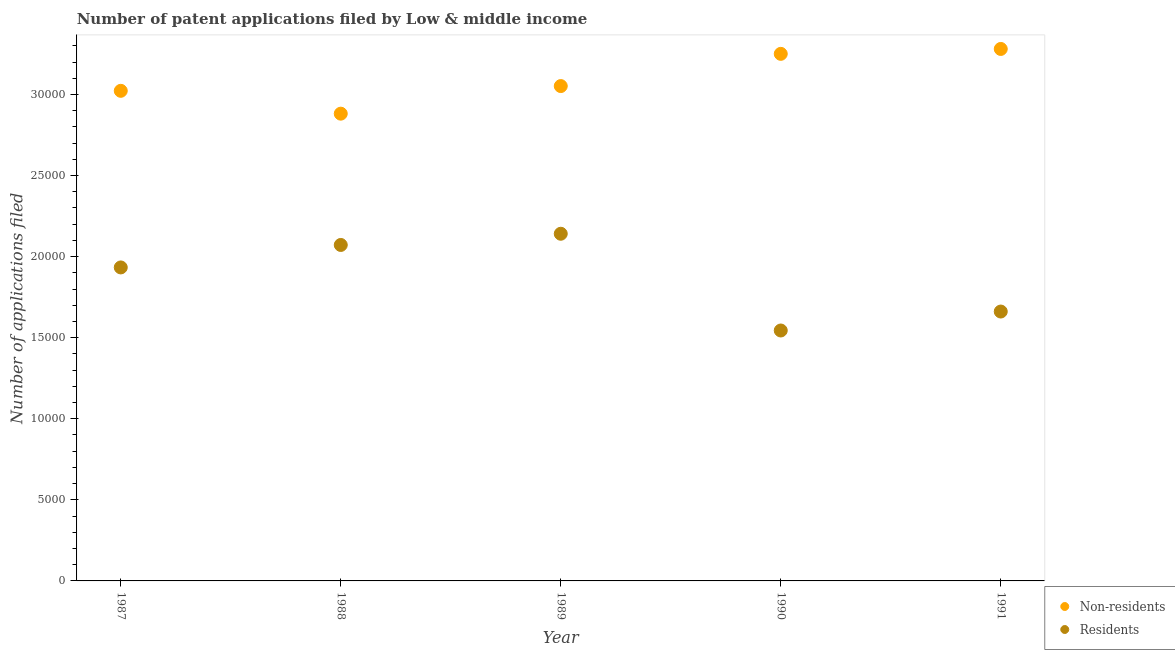How many different coloured dotlines are there?
Make the answer very short. 2. What is the number of patent applications by non residents in 1990?
Offer a terse response. 3.25e+04. Across all years, what is the maximum number of patent applications by non residents?
Ensure brevity in your answer.  3.28e+04. Across all years, what is the minimum number of patent applications by residents?
Keep it short and to the point. 1.54e+04. In which year was the number of patent applications by non residents minimum?
Ensure brevity in your answer.  1988. What is the total number of patent applications by non residents in the graph?
Provide a succinct answer. 1.55e+05. What is the difference between the number of patent applications by residents in 1987 and that in 1991?
Make the answer very short. 2720. What is the difference between the number of patent applications by non residents in 1987 and the number of patent applications by residents in 1988?
Provide a short and direct response. 9505. What is the average number of patent applications by non residents per year?
Ensure brevity in your answer.  3.10e+04. In the year 1987, what is the difference between the number of patent applications by non residents and number of patent applications by residents?
Keep it short and to the point. 1.09e+04. What is the ratio of the number of patent applications by residents in 1987 to that in 1989?
Make the answer very short. 0.9. What is the difference between the highest and the second highest number of patent applications by non residents?
Keep it short and to the point. 302. What is the difference between the highest and the lowest number of patent applications by non residents?
Offer a very short reply. 3991. How many years are there in the graph?
Provide a short and direct response. 5. What is the difference between two consecutive major ticks on the Y-axis?
Provide a succinct answer. 5000. Where does the legend appear in the graph?
Your response must be concise. Bottom right. What is the title of the graph?
Offer a terse response. Number of patent applications filed by Low & middle income. Does "Under-5(male)" appear as one of the legend labels in the graph?
Offer a terse response. No. What is the label or title of the X-axis?
Provide a succinct answer. Year. What is the label or title of the Y-axis?
Your answer should be very brief. Number of applications filed. What is the Number of applications filed in Non-residents in 1987?
Provide a short and direct response. 3.02e+04. What is the Number of applications filed of Residents in 1987?
Offer a terse response. 1.93e+04. What is the Number of applications filed of Non-residents in 1988?
Offer a very short reply. 2.88e+04. What is the Number of applications filed in Residents in 1988?
Offer a very short reply. 2.07e+04. What is the Number of applications filed of Non-residents in 1989?
Make the answer very short. 3.05e+04. What is the Number of applications filed of Residents in 1989?
Your response must be concise. 2.14e+04. What is the Number of applications filed of Non-residents in 1990?
Your answer should be very brief. 3.25e+04. What is the Number of applications filed in Residents in 1990?
Make the answer very short. 1.54e+04. What is the Number of applications filed in Non-residents in 1991?
Make the answer very short. 3.28e+04. What is the Number of applications filed of Residents in 1991?
Provide a short and direct response. 1.66e+04. Across all years, what is the maximum Number of applications filed in Non-residents?
Your answer should be compact. 3.28e+04. Across all years, what is the maximum Number of applications filed in Residents?
Keep it short and to the point. 2.14e+04. Across all years, what is the minimum Number of applications filed of Non-residents?
Provide a short and direct response. 2.88e+04. Across all years, what is the minimum Number of applications filed in Residents?
Your answer should be very brief. 1.54e+04. What is the total Number of applications filed of Non-residents in the graph?
Ensure brevity in your answer.  1.55e+05. What is the total Number of applications filed of Residents in the graph?
Keep it short and to the point. 9.35e+04. What is the difference between the Number of applications filed of Non-residents in 1987 and that in 1988?
Offer a terse response. 1409. What is the difference between the Number of applications filed in Residents in 1987 and that in 1988?
Keep it short and to the point. -1386. What is the difference between the Number of applications filed of Non-residents in 1987 and that in 1989?
Offer a very short reply. -293. What is the difference between the Number of applications filed in Residents in 1987 and that in 1989?
Your response must be concise. -2077. What is the difference between the Number of applications filed in Non-residents in 1987 and that in 1990?
Provide a short and direct response. -2280. What is the difference between the Number of applications filed in Residents in 1987 and that in 1990?
Provide a succinct answer. 3889. What is the difference between the Number of applications filed in Non-residents in 1987 and that in 1991?
Ensure brevity in your answer.  -2582. What is the difference between the Number of applications filed of Residents in 1987 and that in 1991?
Provide a short and direct response. 2720. What is the difference between the Number of applications filed in Non-residents in 1988 and that in 1989?
Provide a short and direct response. -1702. What is the difference between the Number of applications filed of Residents in 1988 and that in 1989?
Provide a short and direct response. -691. What is the difference between the Number of applications filed of Non-residents in 1988 and that in 1990?
Keep it short and to the point. -3689. What is the difference between the Number of applications filed of Residents in 1988 and that in 1990?
Your answer should be very brief. 5275. What is the difference between the Number of applications filed in Non-residents in 1988 and that in 1991?
Your response must be concise. -3991. What is the difference between the Number of applications filed of Residents in 1988 and that in 1991?
Provide a succinct answer. 4106. What is the difference between the Number of applications filed of Non-residents in 1989 and that in 1990?
Your answer should be very brief. -1987. What is the difference between the Number of applications filed in Residents in 1989 and that in 1990?
Give a very brief answer. 5966. What is the difference between the Number of applications filed in Non-residents in 1989 and that in 1991?
Ensure brevity in your answer.  -2289. What is the difference between the Number of applications filed in Residents in 1989 and that in 1991?
Make the answer very short. 4797. What is the difference between the Number of applications filed in Non-residents in 1990 and that in 1991?
Offer a very short reply. -302. What is the difference between the Number of applications filed in Residents in 1990 and that in 1991?
Your answer should be compact. -1169. What is the difference between the Number of applications filed of Non-residents in 1987 and the Number of applications filed of Residents in 1988?
Your response must be concise. 9505. What is the difference between the Number of applications filed of Non-residents in 1987 and the Number of applications filed of Residents in 1989?
Offer a terse response. 8814. What is the difference between the Number of applications filed of Non-residents in 1987 and the Number of applications filed of Residents in 1990?
Provide a succinct answer. 1.48e+04. What is the difference between the Number of applications filed of Non-residents in 1987 and the Number of applications filed of Residents in 1991?
Give a very brief answer. 1.36e+04. What is the difference between the Number of applications filed of Non-residents in 1988 and the Number of applications filed of Residents in 1989?
Your answer should be very brief. 7405. What is the difference between the Number of applications filed in Non-residents in 1988 and the Number of applications filed in Residents in 1990?
Offer a very short reply. 1.34e+04. What is the difference between the Number of applications filed in Non-residents in 1988 and the Number of applications filed in Residents in 1991?
Your response must be concise. 1.22e+04. What is the difference between the Number of applications filed in Non-residents in 1989 and the Number of applications filed in Residents in 1990?
Your answer should be very brief. 1.51e+04. What is the difference between the Number of applications filed in Non-residents in 1989 and the Number of applications filed in Residents in 1991?
Your answer should be compact. 1.39e+04. What is the difference between the Number of applications filed of Non-residents in 1990 and the Number of applications filed of Residents in 1991?
Offer a terse response. 1.59e+04. What is the average Number of applications filed in Non-residents per year?
Make the answer very short. 3.10e+04. What is the average Number of applications filed of Residents per year?
Offer a terse response. 1.87e+04. In the year 1987, what is the difference between the Number of applications filed of Non-residents and Number of applications filed of Residents?
Your answer should be very brief. 1.09e+04. In the year 1988, what is the difference between the Number of applications filed of Non-residents and Number of applications filed of Residents?
Make the answer very short. 8096. In the year 1989, what is the difference between the Number of applications filed in Non-residents and Number of applications filed in Residents?
Offer a terse response. 9107. In the year 1990, what is the difference between the Number of applications filed in Non-residents and Number of applications filed in Residents?
Provide a short and direct response. 1.71e+04. In the year 1991, what is the difference between the Number of applications filed of Non-residents and Number of applications filed of Residents?
Ensure brevity in your answer.  1.62e+04. What is the ratio of the Number of applications filed in Non-residents in 1987 to that in 1988?
Give a very brief answer. 1.05. What is the ratio of the Number of applications filed in Residents in 1987 to that in 1988?
Provide a short and direct response. 0.93. What is the ratio of the Number of applications filed of Non-residents in 1987 to that in 1989?
Provide a succinct answer. 0.99. What is the ratio of the Number of applications filed in Residents in 1987 to that in 1989?
Make the answer very short. 0.9. What is the ratio of the Number of applications filed of Non-residents in 1987 to that in 1990?
Keep it short and to the point. 0.93. What is the ratio of the Number of applications filed in Residents in 1987 to that in 1990?
Your answer should be compact. 1.25. What is the ratio of the Number of applications filed in Non-residents in 1987 to that in 1991?
Your answer should be very brief. 0.92. What is the ratio of the Number of applications filed in Residents in 1987 to that in 1991?
Provide a succinct answer. 1.16. What is the ratio of the Number of applications filed of Non-residents in 1988 to that in 1989?
Your answer should be very brief. 0.94. What is the ratio of the Number of applications filed in Non-residents in 1988 to that in 1990?
Keep it short and to the point. 0.89. What is the ratio of the Number of applications filed in Residents in 1988 to that in 1990?
Ensure brevity in your answer.  1.34. What is the ratio of the Number of applications filed of Non-residents in 1988 to that in 1991?
Your answer should be very brief. 0.88. What is the ratio of the Number of applications filed in Residents in 1988 to that in 1991?
Your response must be concise. 1.25. What is the ratio of the Number of applications filed in Non-residents in 1989 to that in 1990?
Offer a very short reply. 0.94. What is the ratio of the Number of applications filed of Residents in 1989 to that in 1990?
Ensure brevity in your answer.  1.39. What is the ratio of the Number of applications filed of Non-residents in 1989 to that in 1991?
Your response must be concise. 0.93. What is the ratio of the Number of applications filed of Residents in 1989 to that in 1991?
Offer a terse response. 1.29. What is the ratio of the Number of applications filed in Residents in 1990 to that in 1991?
Your response must be concise. 0.93. What is the difference between the highest and the second highest Number of applications filed in Non-residents?
Your response must be concise. 302. What is the difference between the highest and the second highest Number of applications filed of Residents?
Offer a very short reply. 691. What is the difference between the highest and the lowest Number of applications filed in Non-residents?
Give a very brief answer. 3991. What is the difference between the highest and the lowest Number of applications filed in Residents?
Offer a very short reply. 5966. 